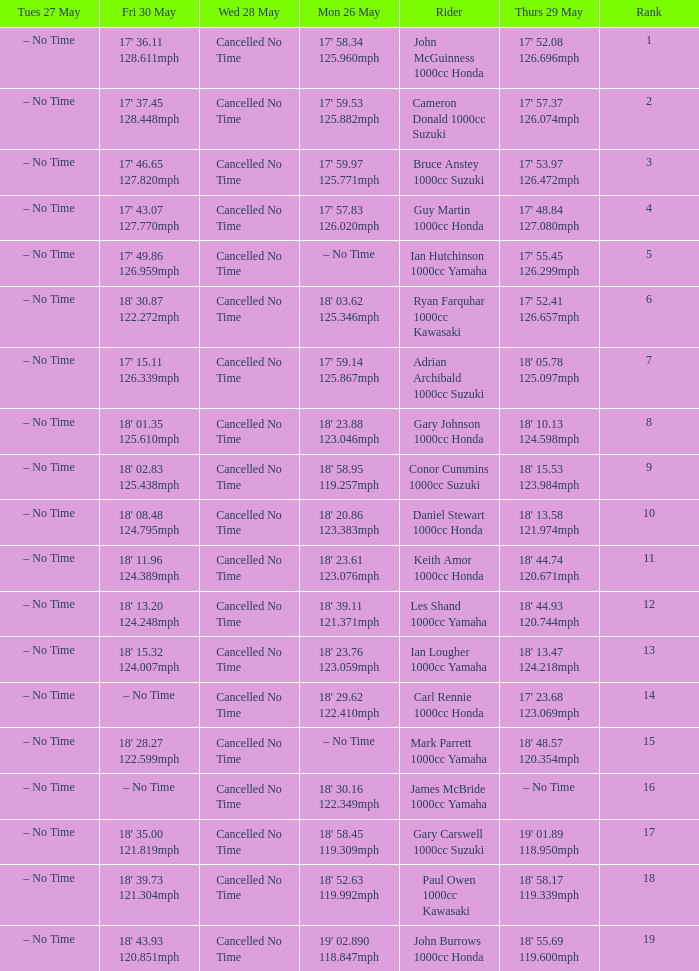What is the numbr for fri may 30 and mon may 26 is 19' 02.890 118.847mph? 18' 43.93 120.851mph. Could you parse the entire table? {'header': ['Tues 27 May', 'Fri 30 May', 'Wed 28 May', 'Mon 26 May', 'Rider', 'Thurs 29 May', 'Rank'], 'rows': [['– No Time', "17' 36.11 128.611mph", 'Cancelled No Time', "17' 58.34 125.960mph", 'John McGuinness 1000cc Honda', "17' 52.08 126.696mph", '1'], ['– No Time', "17' 37.45 128.448mph", 'Cancelled No Time', "17' 59.53 125.882mph", 'Cameron Donald 1000cc Suzuki', "17' 57.37 126.074mph", '2'], ['– No Time', "17' 46.65 127.820mph", 'Cancelled No Time', "17' 59.97 125.771mph", 'Bruce Anstey 1000cc Suzuki', "17' 53.97 126.472mph", '3'], ['– No Time', "17' 43.07 127.770mph", 'Cancelled No Time', "17' 57.83 126.020mph", 'Guy Martin 1000cc Honda', "17' 48.84 127.080mph", '4'], ['– No Time', "17' 49.86 126.959mph", 'Cancelled No Time', '– No Time', 'Ian Hutchinson 1000cc Yamaha', "17' 55.45 126.299mph", '5'], ['– No Time', "18' 30.87 122.272mph", 'Cancelled No Time', "18' 03.62 125.346mph", 'Ryan Farquhar 1000cc Kawasaki', "17' 52.41 126.657mph", '6'], ['– No Time', "17' 15.11 126.339mph", 'Cancelled No Time', "17' 59.14 125.867mph", 'Adrian Archibald 1000cc Suzuki', "18' 05.78 125.097mph", '7'], ['– No Time', "18' 01.35 125.610mph", 'Cancelled No Time', "18' 23.88 123.046mph", 'Gary Johnson 1000cc Honda', "18' 10.13 124.598mph", '8'], ['– No Time', "18' 02.83 125.438mph", 'Cancelled No Time', "18' 58.95 119.257mph", 'Conor Cummins 1000cc Suzuki', "18' 15.53 123.984mph", '9'], ['– No Time', "18' 08.48 124.795mph", 'Cancelled No Time', "18' 20.86 123.383mph", 'Daniel Stewart 1000cc Honda', "18' 13.58 121.974mph", '10'], ['– No Time', "18' 11.96 124.389mph", 'Cancelled No Time', "18' 23.61 123.076mph", 'Keith Amor 1000cc Honda', "18' 44.74 120.671mph", '11'], ['– No Time', "18' 13.20 124.248mph", 'Cancelled No Time', "18' 39.11 121.371mph", 'Les Shand 1000cc Yamaha', "18' 44.93 120.744mph", '12'], ['– No Time', "18' 15.32 124.007mph", 'Cancelled No Time', "18' 23.76 123.059mph", 'Ian Lougher 1000cc Yamaha', "18' 13.47 124.218mph", '13'], ['– No Time', '– No Time', 'Cancelled No Time', "18' 29.62 122.410mph", 'Carl Rennie 1000cc Honda', "17' 23.68 123.069mph", '14'], ['– No Time', "18' 28.27 122.599mph", 'Cancelled No Time', '– No Time', 'Mark Parrett 1000cc Yamaha', "18' 48.57 120.354mph", '15'], ['– No Time', '– No Time', 'Cancelled No Time', "18' 30.16 122.349mph", 'James McBride 1000cc Yamaha', '– No Time', '16'], ['– No Time', "18' 35.00 121.819mph", 'Cancelled No Time', "18' 58.45 119.309mph", 'Gary Carswell 1000cc Suzuki', "19' 01.89 118.950mph", '17'], ['– No Time', "18' 39.73 121.304mph", 'Cancelled No Time', "18' 52.63 119.992mph", 'Paul Owen 1000cc Kawasaki', "18' 58.17 119.339mph", '18'], ['– No Time', "18' 43.93 120.851mph", 'Cancelled No Time', "19' 02.890 118.847mph", 'John Burrows 1000cc Honda', "18' 55.69 119.600mph", '19']]} 